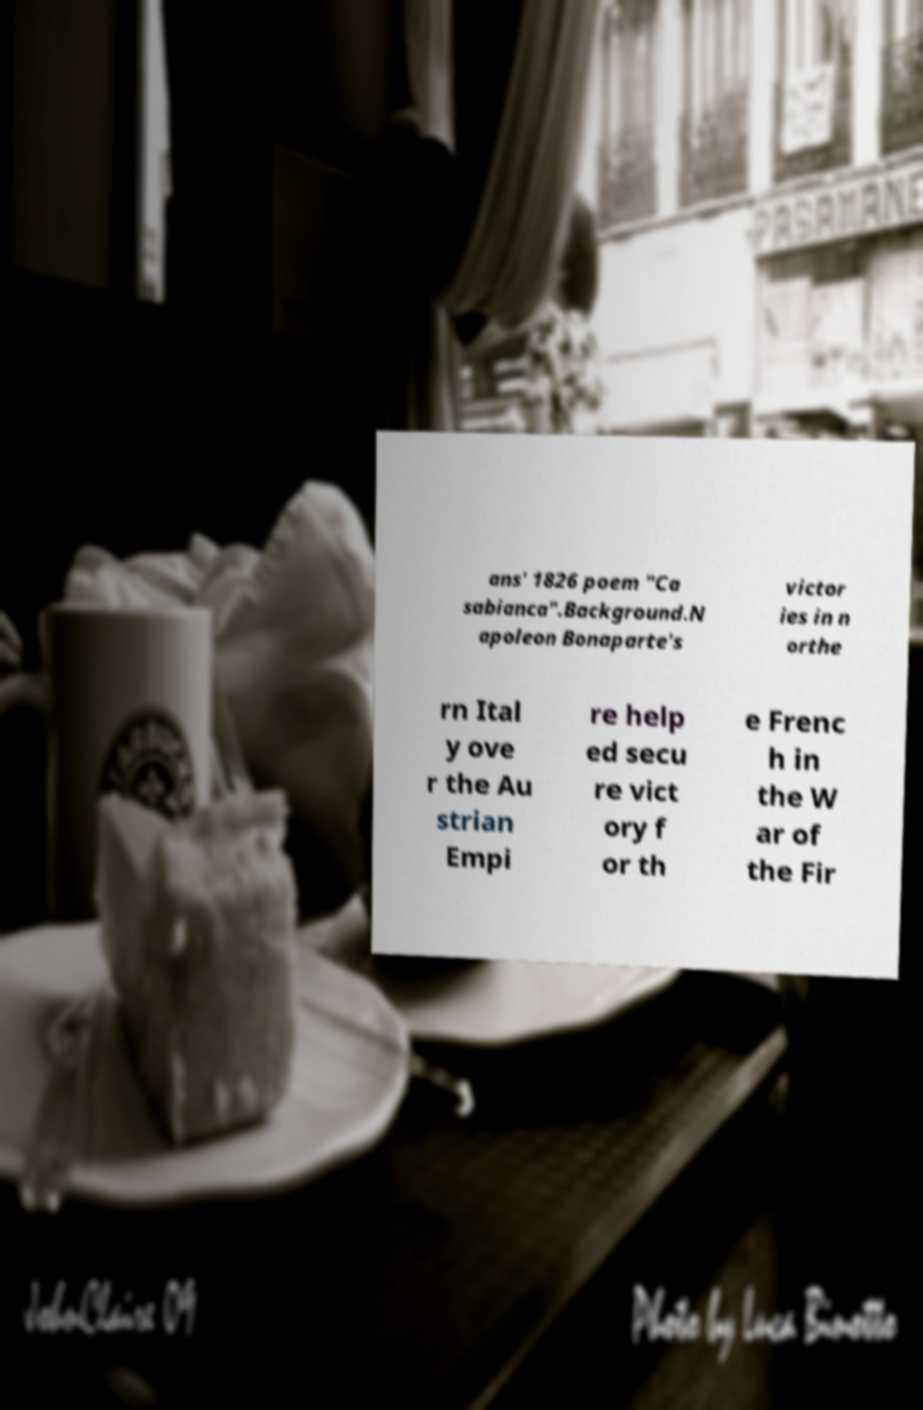Can you read and provide the text displayed in the image?This photo seems to have some interesting text. Can you extract and type it out for me? ans' 1826 poem "Ca sabianca".Background.N apoleon Bonaparte's victor ies in n orthe rn Ital y ove r the Au strian Empi re help ed secu re vict ory f or th e Frenc h in the W ar of the Fir 